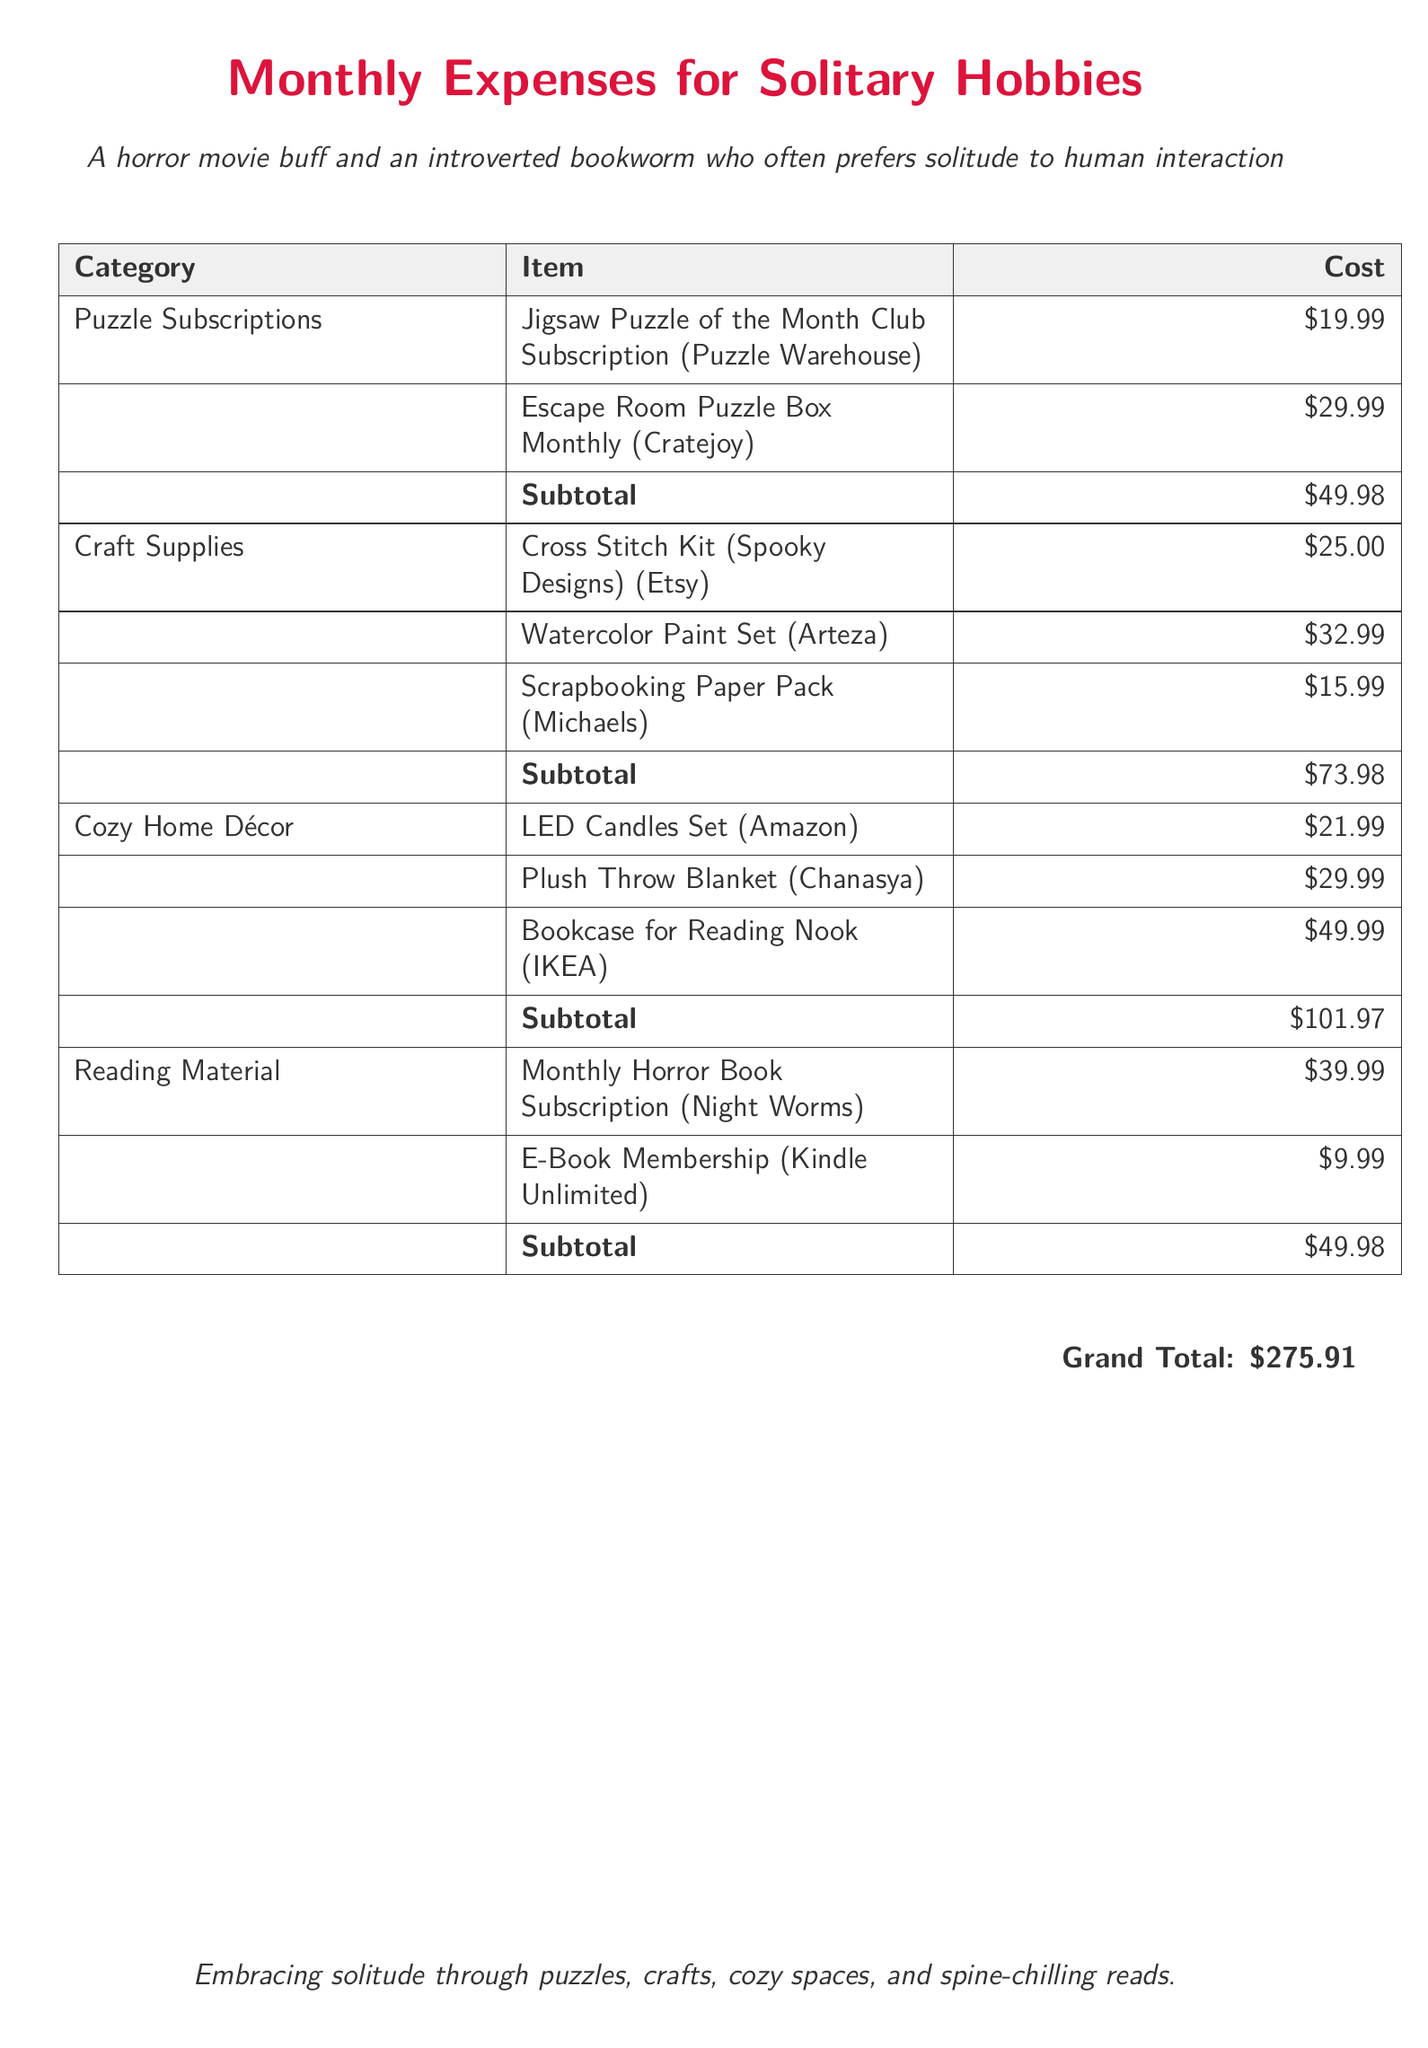What is the total cost for puzzle subscriptions? The subtotal for puzzle subscriptions is the sum of individual items in that category, which is $19.99 + $29.99 = $49.98.
Answer: $49.98 How much was spent on craft supplies? The subtotal for craft supplies is calculated from the listed items, resulting in $25.00 + $32.99 + $15.99 = $73.98.
Answer: $73.98 What is the total amount spent on cozy home décor? By adding up the costs of cozy home décor items, the subtotal is $21.99 + $29.99 + $49.99 = $101.97.
Answer: $101.97 What is the cost of the monthly horror book subscription? The cost is listed directly in the document under reading material as $39.99.
Answer: $39.99 How many categories of expenses are listed in the document? The document lists four distinct categories of expenses related to solitary hobbies.
Answer: 4 What is the grand total of all expenses? The grand total is the sum of all subtotals across the categories, which totals $275.91.
Answer: $275.91 How many items are included in the craft supplies category? The craft supplies category contains three items according to the breakdown in the document.
Answer: 3 What type of decor is mentioned for creating a reading nook? The listed item for the reading nook is a bookcase specifically mentioned under cozy home décor.
Answer: Bookcase for Reading Nook Which subscription has the highest cost? The escape room puzzle box monthly subscription is the highest cost listed at $29.99.
Answer: Escape Room Puzzle Box Monthly 